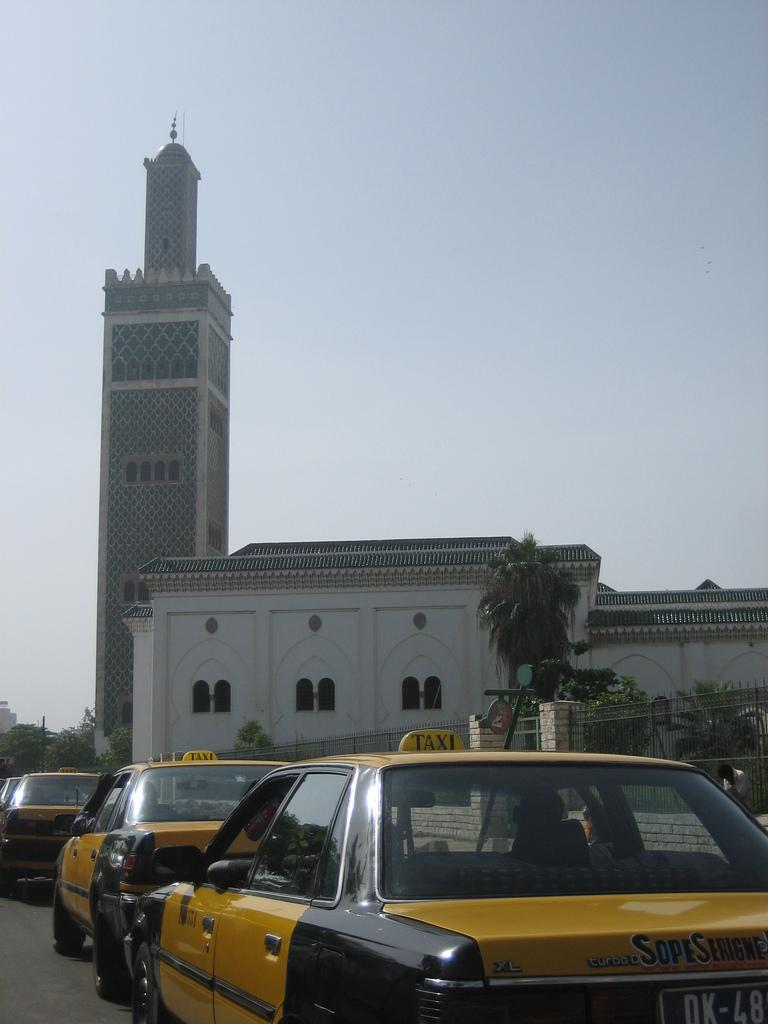What can be seen on the road in the image? There are cars on the road in the image. What type of structure is visible in the image? There is a building with windows in the image. What type of vegetation is present in the image? There are trees in the image. Who or what is present in the image? There is a person in the image. What is visible in the background of the image? The sky is visible in the background of the image. What type of leg is visible on the person in the image? There is no specific leg visible on the person in the image; only a person is mentioned. What type of throne is present in the image? There is no throne present in the image. 